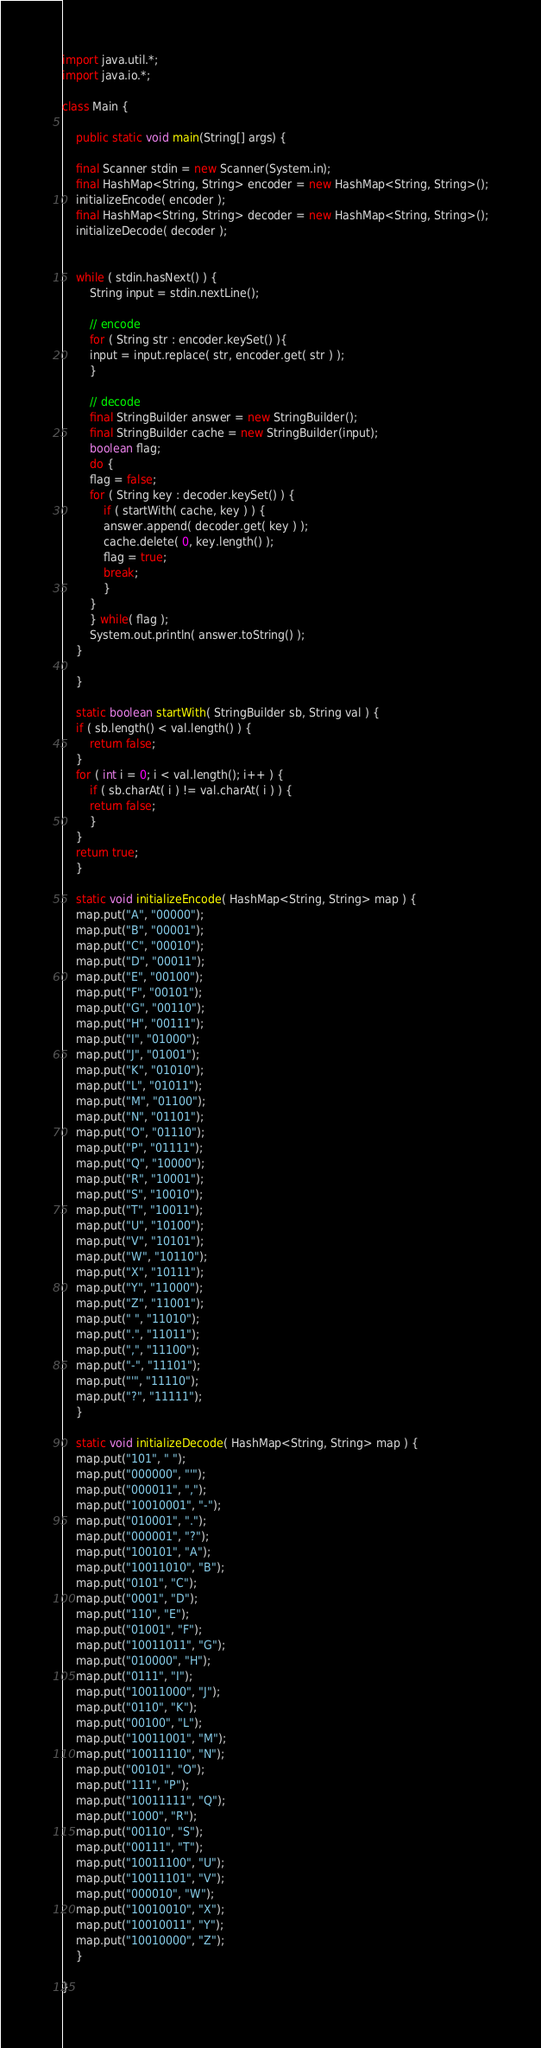<code> <loc_0><loc_0><loc_500><loc_500><_Java_>import java.util.*;
import java.io.*;

class Main {

    public static void main(String[] args) {

	final Scanner stdin = new Scanner(System.in);
	final HashMap<String, String> encoder = new HashMap<String, String>();
	initializeEncode( encoder );
	final HashMap<String, String> decoder = new HashMap<String, String>();
	initializeDecode( decoder );

	
	while ( stdin.hasNext() ) {
	    String input = stdin.nextLine();
	    
	    // encode
	    for ( String str : encoder.keySet() ){
		input = input.replace( str, encoder.get( str ) );
	    }

	    // decode
	    final StringBuilder answer = new StringBuilder();
	    final StringBuilder cache = new StringBuilder(input);
	    boolean flag;
	    do {
		flag = false;
		for ( String key : decoder.keySet() ) {
		    if ( startWith( cache, key ) ) {
			answer.append( decoder.get( key ) );
			cache.delete( 0, key.length() );
			flag = true;
			break;
		    }
		}		
	    } while( flag );
	    System.out.println( answer.toString() );		    
	}
	
    }

    static boolean startWith( StringBuilder sb, String val ) {
	if ( sb.length() < val.length() ) {
	    return false;
	}
	for ( int i = 0; i < val.length(); i++ ) {
	    if ( sb.charAt( i ) != val.charAt( i ) ) {
		return false;
	    } 
	}
	return true;
    }

    static void initializeEncode( HashMap<String, String> map ) {
	map.put("A", "00000");
	map.put("B", "00001");
	map.put("C", "00010");
	map.put("D", "00011");
	map.put("E", "00100");
	map.put("F", "00101");
	map.put("G", "00110");
	map.put("H", "00111");
	map.put("I", "01000");
	map.put("J", "01001");
	map.put("K", "01010");
	map.put("L", "01011");
	map.put("M", "01100");
	map.put("N", "01101");
	map.put("O", "01110");
	map.put("P", "01111");
	map.put("Q", "10000");
	map.put("R", "10001");
	map.put("S", "10010");
	map.put("T", "10011");
	map.put("U", "10100");
	map.put("V", "10101");
	map.put("W", "10110");
	map.put("X", "10111");
	map.put("Y", "11000");
	map.put("Z", "11001");
	map.put(" ", "11010");
	map.put(".", "11011");
	map.put(",", "11100");
	map.put("-", "11101");
	map.put("'", "11110");
	map.put("?", "11111");
    }

    static void initializeDecode( HashMap<String, String> map ) {
	map.put("101", " ");
	map.put("000000", "'");
	map.put("000011", ",");
	map.put("10010001", "-");
	map.put("010001", ".");
	map.put("000001", "?");
	map.put("100101", "A");
	map.put("10011010", "B");
	map.put("0101", "C");
	map.put("0001", "D");
	map.put("110", "E");
	map.put("01001", "F");
	map.put("10011011", "G");
	map.put("010000", "H");
	map.put("0111", "I");
	map.put("10011000", "J");
	map.put("0110", "K");
	map.put("00100", "L");
	map.put("10011001", "M");
	map.put("10011110", "N");
	map.put("00101", "O");
	map.put("111", "P");
	map.put("10011111", "Q");
	map.put("1000", "R");
	map.put("00110", "S");
	map.put("00111", "T");
	map.put("10011100", "U");
	map.put("10011101", "V");
	map.put("000010", "W");
	map.put("10010010", "X");
	map.put("10010011", "Y");
	map.put("10010000", "Z");
    }
    
}</code> 